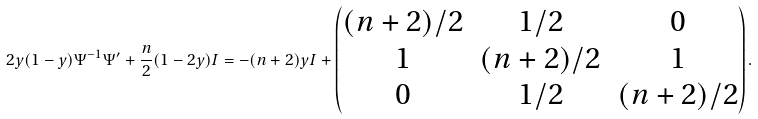Convert formula to latex. <formula><loc_0><loc_0><loc_500><loc_500>2 y ( 1 - y ) \Psi ^ { - 1 } \Psi ^ { \prime } + \frac { n } { 2 } ( 1 - 2 y ) I = - ( n + 2 ) y I + \left ( \begin{matrix} ( n + 2 ) / 2 & 1 / 2 & 0 \\ 1 & ( n + 2 ) / 2 & 1 \\ 0 & 1 / 2 & ( n + 2 ) / 2 \end{matrix} \right ) .</formula> 